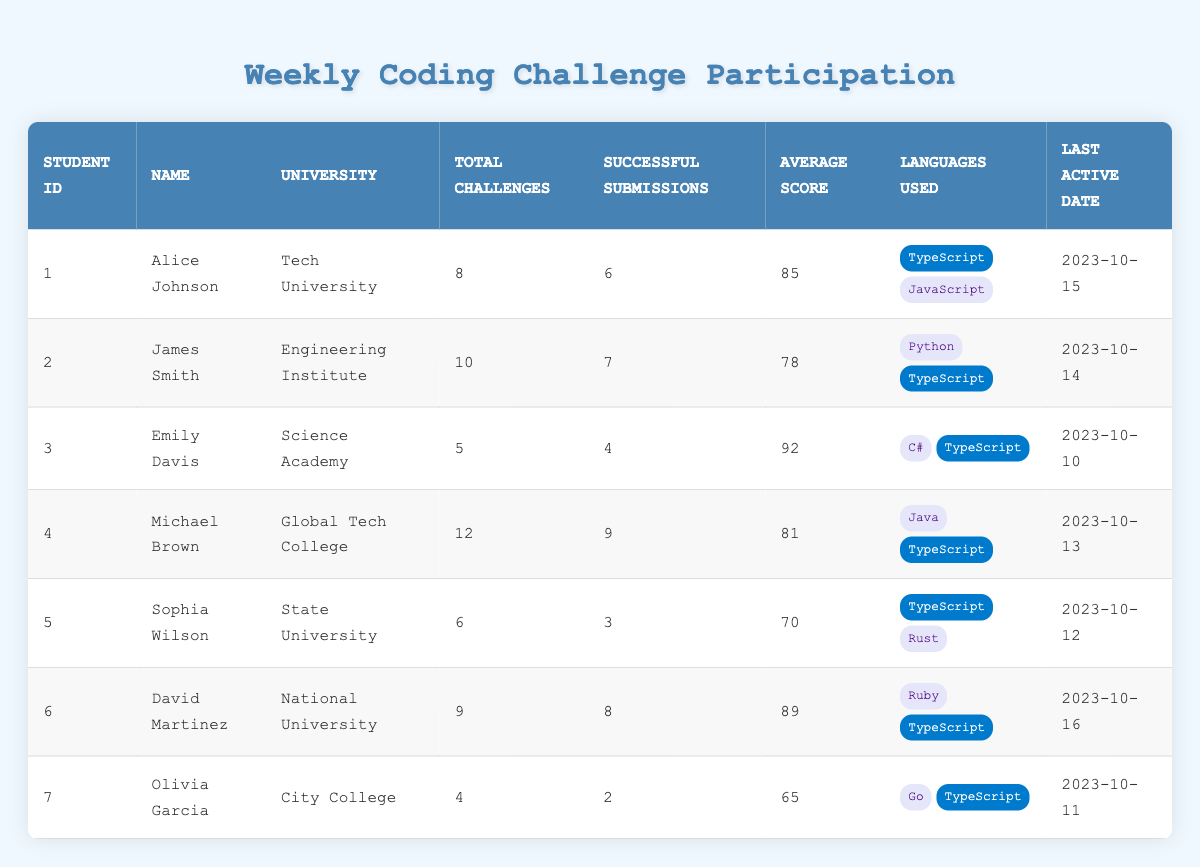What is the total number of challenges participated by David Martinez? David Martinez's total challenges can be found in the "Total Challenges" column of his row in the table. He participated in a total of 9 challenges.
Answer: 9 Which student has the highest average score? To find the highest average score, we need to review the "Average Score" column for all students. The scores are: Alice Johnson (85), James Smith (78), Emily Davis (92), Michael Brown (81), Sophia Wilson (70), David Martinez (89), and Olivia Garcia (65). Emily Davis has the highest score of 92.
Answer: Emily Davis How many students used TypeScript as one of their languages? From the "Languages Used" column, we can check each student's languages. Alice Johnson, James Smith, Emily Davis, Michael Brown, Sophia Wilson, David Martinez, and Olivia Garcia all used TypeScript, totaling 7 students.
Answer: 7 What is the difference between the total challenges participated by Michael Brown and Sophia Wilson? First, find the total challenges for Michael Brown (12) and Sophia Wilson (6). Then, calculate the difference: 12 - 6 = 6. Therefore, the difference in their total challenges is 6.
Answer: 6 Did Olivia Garcia receive a score above 70? To find out, we can check Olivia Garcia's average score in the table, which shows she received a score of 65. Since 65 is not above 70, the answer is no.
Answer: No What is the average score of all students who participated in coding challenges? To calculate the average score, we add the average scores of all students (85 + 78 + 92 + 81 + 70 + 89 + 65 = 560), then divide by the total number of students (7): 560 / 7 = 80. Therefore, the average score across all students is 80.
Answer: 80 Who has the second highest number of successful submissions? We must compare the "Successful Submissions" for all the students. The numbers are as follows: Alice Johnson (6), James Smith (7), Emily Davis (4), Michael Brown (9), Sophia Wilson (3), David Martinez (8), and Olivia Garcia (2). Michael Brown has the highest at 9, while David Martinez has the second highest with 8 successful submissions.
Answer: David Martinez How many total challenges did students from Tech University and National University participate in? For Tech University, Alice Johnson participated in 8 challenges and for National University, David Martinez participated in 9 challenges. By adding these two together: 8 + 9 = 17. Thus, the total challenges from both universities is 17.
Answer: 17 Which language is most commonly used among the students listed in the table? By looking at the "Languages Used" column, we can see that TypeScript appears in the languages of all 7 students, making it the most commonly used language.
Answer: TypeScript 